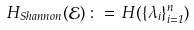Convert formula to latex. <formula><loc_0><loc_0><loc_500><loc_500>H _ { S h a n n o n } ( { \mathcal { E } } ) \, \colon = \, H ( \{ \lambda _ { i } \} _ { i = 1 } ^ { n } )</formula> 